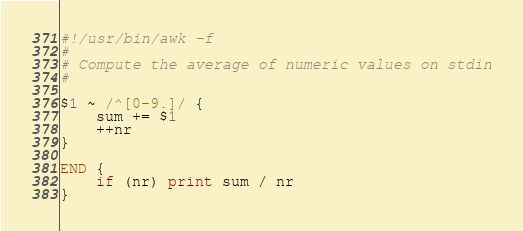Convert code to text. <code><loc_0><loc_0><loc_500><loc_500><_Awk_>#!/usr/bin/awk -f
# 
# Compute the average of numeric values on stdin
#

$1 ~ /^[0-9.]/ {
    sum += $1
    ++nr
}

END {
    if (nr) print sum / nr
}
</code> 